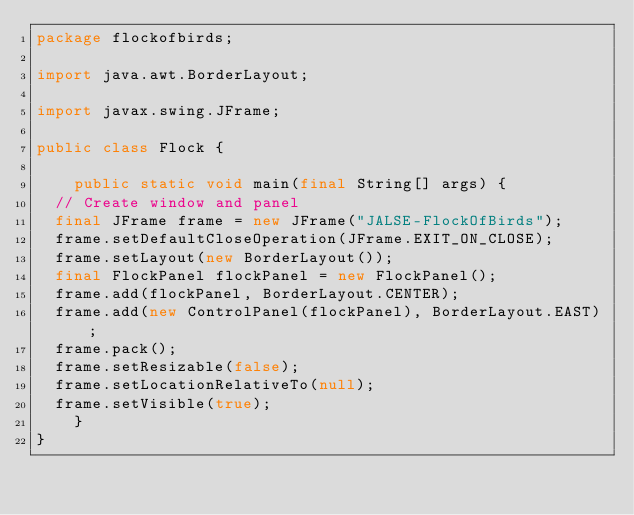Convert code to text. <code><loc_0><loc_0><loc_500><loc_500><_Java_>package flockofbirds;

import java.awt.BorderLayout;

import javax.swing.JFrame;

public class Flock {

    public static void main(final String[] args) {
	// Create window and panel
	final JFrame frame = new JFrame("JALSE-FlockOfBirds");
	frame.setDefaultCloseOperation(JFrame.EXIT_ON_CLOSE);
	frame.setLayout(new BorderLayout());
	final FlockPanel flockPanel = new FlockPanel();
	frame.add(flockPanel, BorderLayout.CENTER);
	frame.add(new ControlPanel(flockPanel), BorderLayout.EAST);
	frame.pack();
	frame.setResizable(false);
	frame.setLocationRelativeTo(null);
	frame.setVisible(true);
    }
}
</code> 